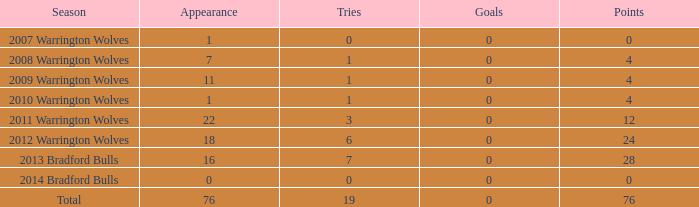What is the typical number of tries for the warrington wolves in the 2008 season with more than 7 appearances? None. 